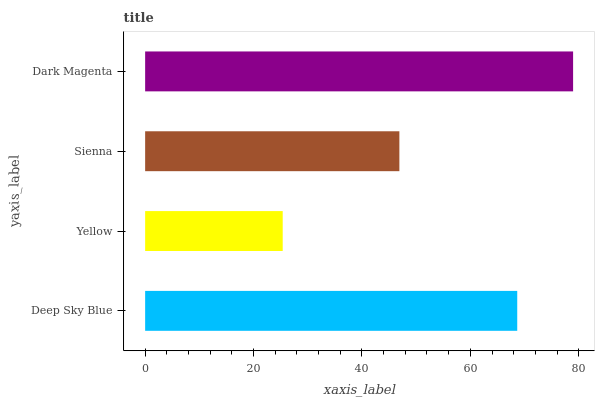Is Yellow the minimum?
Answer yes or no. Yes. Is Dark Magenta the maximum?
Answer yes or no. Yes. Is Sienna the minimum?
Answer yes or no. No. Is Sienna the maximum?
Answer yes or no. No. Is Sienna greater than Yellow?
Answer yes or no. Yes. Is Yellow less than Sienna?
Answer yes or no. Yes. Is Yellow greater than Sienna?
Answer yes or no. No. Is Sienna less than Yellow?
Answer yes or no. No. Is Deep Sky Blue the high median?
Answer yes or no. Yes. Is Sienna the low median?
Answer yes or no. Yes. Is Sienna the high median?
Answer yes or no. No. Is Dark Magenta the low median?
Answer yes or no. No. 